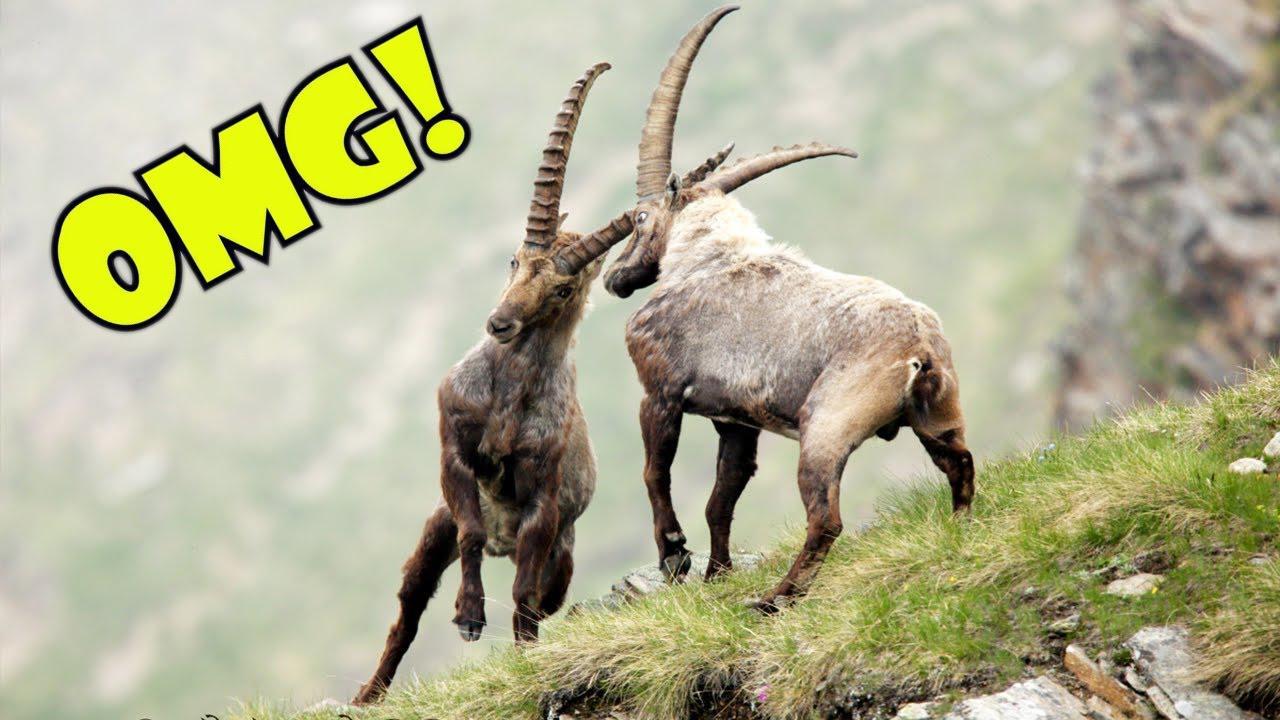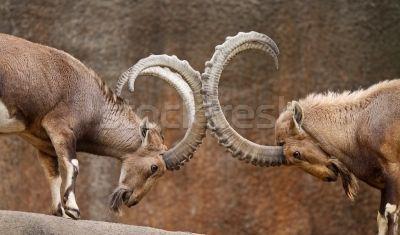The first image is the image on the left, the second image is the image on the right. Considering the images on both sides, is "Two rams are locking horns in each of the images." valid? Answer yes or no. Yes. 